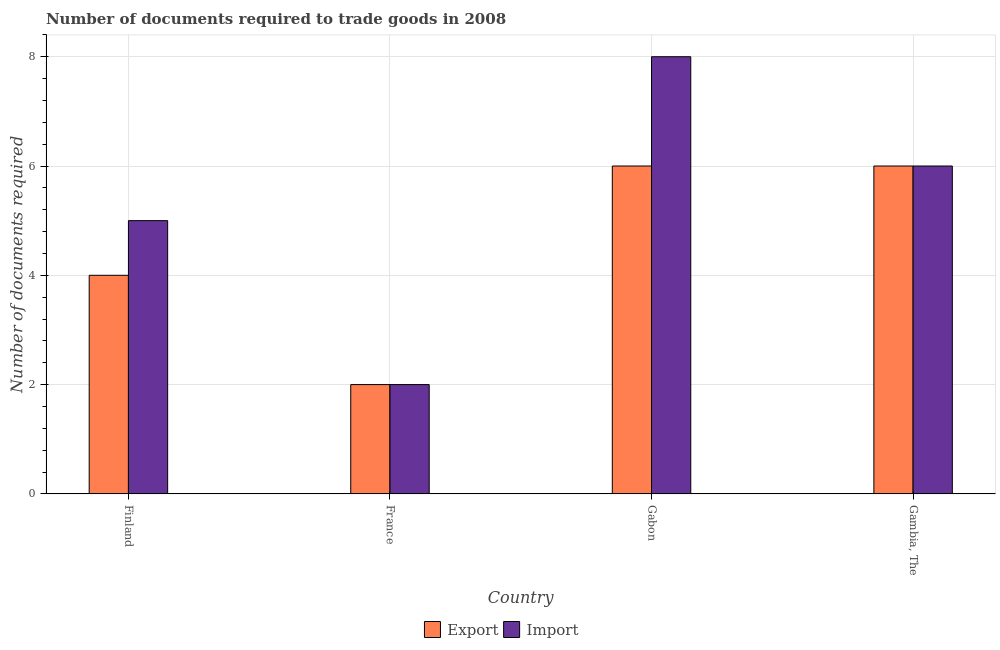How many different coloured bars are there?
Offer a very short reply. 2. Are the number of bars on each tick of the X-axis equal?
Offer a very short reply. Yes. How many bars are there on the 3rd tick from the left?
Your answer should be very brief. 2. What is the label of the 1st group of bars from the left?
Your answer should be very brief. Finland. In how many cases, is the number of bars for a given country not equal to the number of legend labels?
Provide a short and direct response. 0. What is the number of documents required to export goods in France?
Give a very brief answer. 2. Across all countries, what is the maximum number of documents required to import goods?
Make the answer very short. 8. In which country was the number of documents required to import goods maximum?
Your answer should be very brief. Gabon. What is the difference between the number of documents required to import goods in Gambia, The and the number of documents required to export goods in France?
Provide a succinct answer. 4. In how many countries, is the number of documents required to export goods greater than 1.6 ?
Offer a terse response. 4. What is the ratio of the number of documents required to import goods in Finland to that in France?
Offer a very short reply. 2.5. Is the difference between the number of documents required to export goods in Finland and Gabon greater than the difference between the number of documents required to import goods in Finland and Gabon?
Provide a short and direct response. Yes. What is the difference between the highest and the second highest number of documents required to import goods?
Your response must be concise. 2. What is the difference between the highest and the lowest number of documents required to export goods?
Offer a very short reply. 4. In how many countries, is the number of documents required to import goods greater than the average number of documents required to import goods taken over all countries?
Offer a very short reply. 2. Is the sum of the number of documents required to export goods in France and Gambia, The greater than the maximum number of documents required to import goods across all countries?
Ensure brevity in your answer.  No. What does the 1st bar from the left in Gabon represents?
Your response must be concise. Export. What does the 1st bar from the right in Finland represents?
Offer a terse response. Import. How many bars are there?
Provide a short and direct response. 8. Are all the bars in the graph horizontal?
Your response must be concise. No. How many countries are there in the graph?
Make the answer very short. 4. Are the values on the major ticks of Y-axis written in scientific E-notation?
Your response must be concise. No. Does the graph contain any zero values?
Your answer should be very brief. No. Where does the legend appear in the graph?
Make the answer very short. Bottom center. What is the title of the graph?
Provide a succinct answer. Number of documents required to trade goods in 2008. Does "State government" appear as one of the legend labels in the graph?
Offer a terse response. No. What is the label or title of the Y-axis?
Your answer should be very brief. Number of documents required. What is the Number of documents required in Import in Finland?
Keep it short and to the point. 5. What is the Number of documents required of Export in France?
Your answer should be compact. 2. What is the Number of documents required in Import in France?
Keep it short and to the point. 2. What is the Number of documents required in Export in Gabon?
Your answer should be compact. 6. What is the Number of documents required in Import in Gabon?
Ensure brevity in your answer.  8. What is the Number of documents required of Import in Gambia, The?
Make the answer very short. 6. Across all countries, what is the maximum Number of documents required of Export?
Your answer should be very brief. 6. Across all countries, what is the maximum Number of documents required in Import?
Your response must be concise. 8. Across all countries, what is the minimum Number of documents required of Export?
Provide a short and direct response. 2. What is the total Number of documents required in Export in the graph?
Your answer should be very brief. 18. What is the difference between the Number of documents required of Import in Finland and that in France?
Ensure brevity in your answer.  3. What is the difference between the Number of documents required in Export in Finland and that in Gabon?
Your answer should be compact. -2. What is the difference between the Number of documents required in Import in Finland and that in Gabon?
Give a very brief answer. -3. What is the difference between the Number of documents required in Export in Finland and that in Gambia, The?
Make the answer very short. -2. What is the difference between the Number of documents required in Import in Gabon and that in Gambia, The?
Provide a succinct answer. 2. What is the difference between the Number of documents required in Export in Finland and the Number of documents required in Import in France?
Offer a terse response. 2. What is the difference between the Number of documents required of Export in France and the Number of documents required of Import in Gabon?
Your response must be concise. -6. What is the difference between the Number of documents required of Export in France and the Number of documents required of Import in Gambia, The?
Provide a short and direct response. -4. What is the average Number of documents required of Export per country?
Your answer should be compact. 4.5. What is the average Number of documents required in Import per country?
Keep it short and to the point. 5.25. What is the difference between the Number of documents required of Export and Number of documents required of Import in Finland?
Ensure brevity in your answer.  -1. What is the ratio of the Number of documents required of Export in Finland to that in France?
Ensure brevity in your answer.  2. What is the ratio of the Number of documents required of Import in France to that in Gambia, The?
Offer a very short reply. 0.33. What is the ratio of the Number of documents required in Export in Gabon to that in Gambia, The?
Offer a terse response. 1. What is the difference between the highest and the second highest Number of documents required in Export?
Keep it short and to the point. 0. What is the difference between the highest and the second highest Number of documents required in Import?
Keep it short and to the point. 2. What is the difference between the highest and the lowest Number of documents required in Export?
Your answer should be very brief. 4. What is the difference between the highest and the lowest Number of documents required in Import?
Keep it short and to the point. 6. 